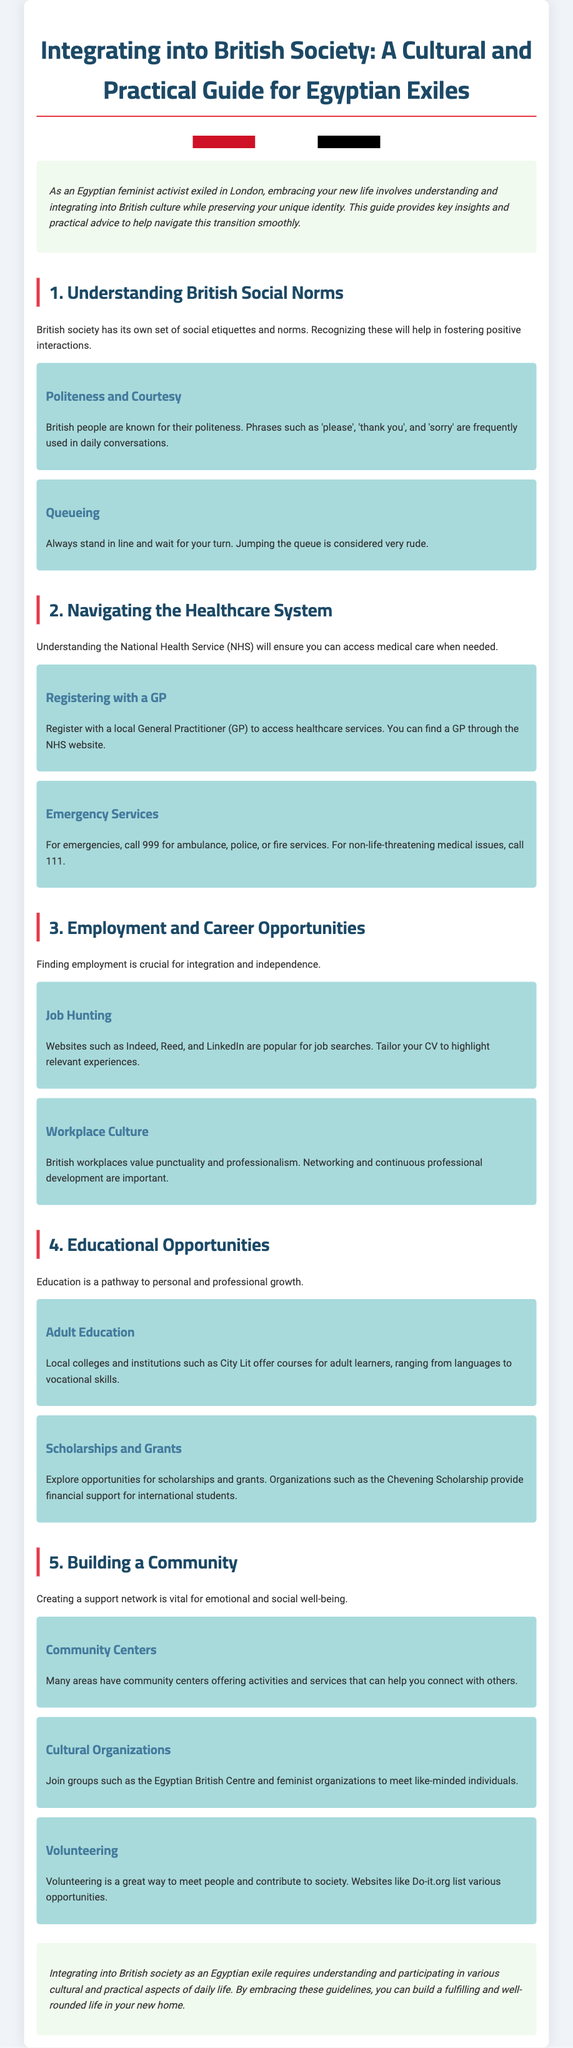what is the title of the guide? The title of the guide is prominently displayed at the beginning of the document.
Answer: Integrating into British Society: A Cultural and Practical Guide for Egyptian Exiles what is a key aspect of British social norms mentioned? The document highlights the cultural significance of politeness in British society.
Answer: Politeness and Courtesy what should you do for emergency medical services? The guide provides information on what action to take in case of emergencies.
Answer: Call 999 what is recommended for job hunting? The document suggests specific websites to aid in job searching.
Answer: Indeed, Reed, and LinkedIn which type of organizations can help build community connections? The guide mentions various organizations that can provide support for exiles.
Answer: Cultural Organizations how can volunteering benefit you in a new country? The document explains the advantages of volunteering in British society.
Answer: Meet people and contribute to society what is suggested for adult education? The guide provides options for further education opportunities for adults.
Answer: Local colleges and institutions which service should you register with to access healthcare? The document states a specific healthcare service related to registration.
Answer: General Practitioner (GP) 